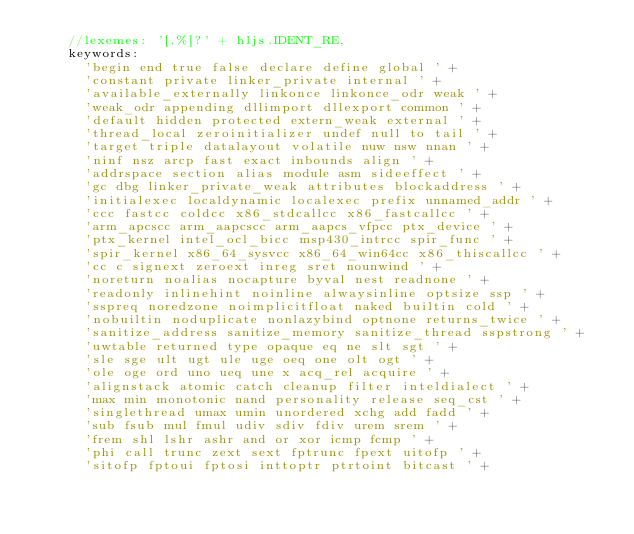Convert code to text. <code><loc_0><loc_0><loc_500><loc_500><_JavaScript_>    //lexemes: '[.%]?' + hljs.IDENT_RE,
    keywords:
      'begin end true false declare define global ' +
      'constant private linker_private internal ' +
      'available_externally linkonce linkonce_odr weak ' +
      'weak_odr appending dllimport dllexport common ' +
      'default hidden protected extern_weak external ' +
      'thread_local zeroinitializer undef null to tail ' +
      'target triple datalayout volatile nuw nsw nnan ' +
      'ninf nsz arcp fast exact inbounds align ' +
      'addrspace section alias module asm sideeffect ' +
      'gc dbg linker_private_weak attributes blockaddress ' +
      'initialexec localdynamic localexec prefix unnamed_addr ' +
      'ccc fastcc coldcc x86_stdcallcc x86_fastcallcc ' +
      'arm_apcscc arm_aapcscc arm_aapcs_vfpcc ptx_device ' +
      'ptx_kernel intel_ocl_bicc msp430_intrcc spir_func ' +
      'spir_kernel x86_64_sysvcc x86_64_win64cc x86_thiscallcc ' +
      'cc c signext zeroext inreg sret nounwind ' +
      'noreturn noalias nocapture byval nest readnone ' +
      'readonly inlinehint noinline alwaysinline optsize ssp ' +
      'sspreq noredzone noimplicitfloat naked builtin cold ' +
      'nobuiltin noduplicate nonlazybind optnone returns_twice ' +
      'sanitize_address sanitize_memory sanitize_thread sspstrong ' +
      'uwtable returned type opaque eq ne slt sgt ' +
      'sle sge ult ugt ule uge oeq one olt ogt ' +
      'ole oge ord uno ueq une x acq_rel acquire ' +
      'alignstack atomic catch cleanup filter inteldialect ' +
      'max min monotonic nand personality release seq_cst ' +
      'singlethread umax umin unordered xchg add fadd ' +
      'sub fsub mul fmul udiv sdiv fdiv urem srem ' +
      'frem shl lshr ashr and or xor icmp fcmp ' +
      'phi call trunc zext sext fptrunc fpext uitofp ' +
      'sitofp fptoui fptosi inttoptr ptrtoint bitcast ' +</code> 